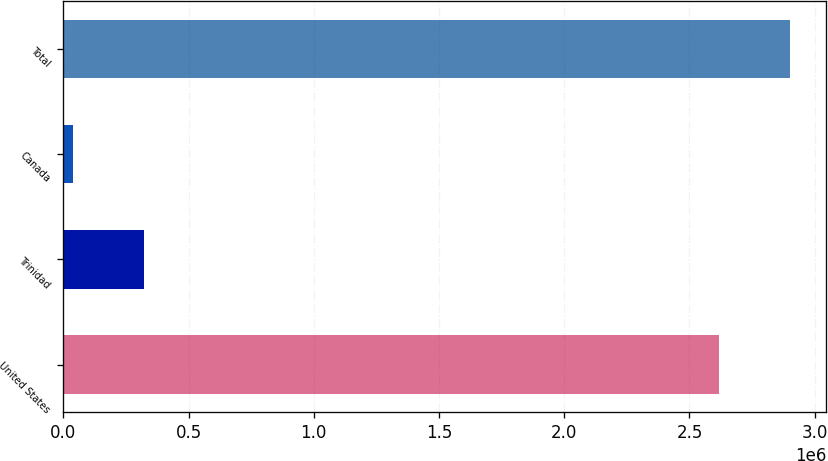<chart> <loc_0><loc_0><loc_500><loc_500><bar_chart><fcel>United States<fcel>Trinidad<fcel>Canada<fcel>Total<nl><fcel>2.61862e+06<fcel>322845<fcel>40000<fcel>2.90147e+06<nl></chart> 